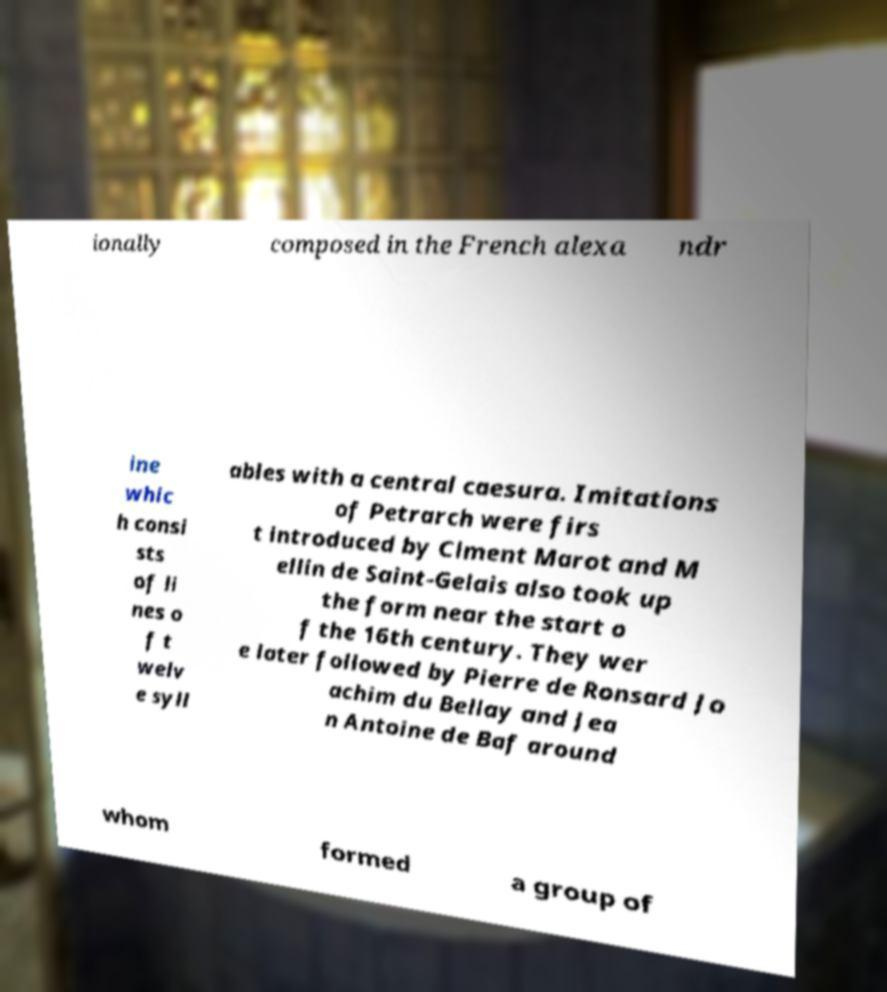Can you read and provide the text displayed in the image?This photo seems to have some interesting text. Can you extract and type it out for me? ionally composed in the French alexa ndr ine whic h consi sts of li nes o f t welv e syll ables with a central caesura. Imitations of Petrarch were firs t introduced by Clment Marot and M ellin de Saint-Gelais also took up the form near the start o f the 16th century. They wer e later followed by Pierre de Ronsard Jo achim du Bellay and Jea n Antoine de Baf around whom formed a group of 